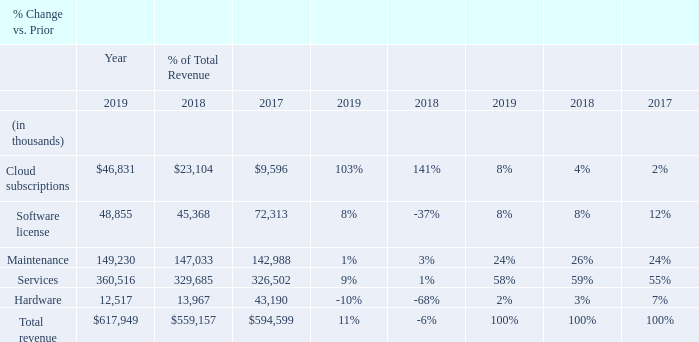Revenue
Our revenue consists of fees generated from cloud subscriptions, software licensing, maintenance, professional services, and hardware sales.
Cloud Subscriptions Revenue Year 2019 compared with year 2018 In 2017, we released Manhattan Active™ Solutions accelerating our business transition to cloud subscriptions. As a result, cloud subscriptions revenue increased $23.7 million, or 103%, to $46.8 million in 2019 compared to 2018 as customers began to purchase. our SaaS offerings rather than a traditional perpetual license. Our customers increasingly prefer cloud-based solutions, including existing customers that are migrating from on-premise to cloud-based offerings. Cloud subscriptions revenue for the Americas, EMEA and APAC segments increased $20.3 million, $2.7 million and $0.7 million, respectively.
Year 2018 compared with year 2017
Cloud subscriptions revenue increased $13.5 million to $23.1 million in 2018 compared to 2017 as customers began to purchase our SaaS offerings rather than a traditional perpetual license. Cloud subscriptions revenue for the Americas, EMEA and APAC segments increased $11.3 million, $1.8 million and $0.4 million, respectively. The EMEA segment began recognizing cloud subscription revenue for the first time in 2017 while the APAC segment began in 2018.
Software License Revenue Year 2019 compared with year 2018 Software license revenue increased $3.5 million to $48.9 million in 2019 compared to 2018. License revenue for the Americas and EMEA segments increased $6.1 million and $0.1 million, respectively, and license revenue for the APAC segment decreased $2.7 million, in 2019 over 2018. The perpetual license sales percentage mix across our product suite in 2019 was approximately 80% warehouse management solutions.
Year 2018 compared with year 2017 Software license revenue decreased $26.9 million to $45.4 million in 2018 compared to 2017. The decrease was influenced by (1) extended sales cycles and evaluations for some of our contracts, and (2) the business transition to cloud subscriptions, which resulted in traditional perpetual license deals closing as cloud deals based on customer demand. License revenue for the Americas and EMEA segments decreased $15.7 million and $11.5 million, respectively, in 2018 over 2017, while license revenue for the APAC segment increased $0.3 million. The perpetual license sales percentage mix across our product suite in 2018 was approximately 80% warehouse management solutions.
Software license revenue decreased $26.9 million to $45.4 million in 2018 compared to 2017. The decrease was influenced by (1)
extended sales cycles and evaluations for some of our contracts, and (2) the business transition to cloud subscriptions, which resulted
in traditional perpetual license deals closing as cloud deals based on customer demand. License revenue for the Americas and EMEA segments decreased $15.7 million and $11.5 million, respectively, in 2018 over 2017, while license revenue for the APAC segment increased $0.3 million. The perpetual license sales percentage mix across our product suite in 2018 was approximately 80% warehouse management solutions.
Maintenance Revenue
Year 2019 compared with year 2018
Maintenance revenue increased $2.2 million in 2019 compared to 2018 primarily due to (1) an increase in the first-year maintenance revenue; (2) our annual renewal rate of customers subscribing to maintenance, which was greater than 90%; and (3) increases in the maintenance renewal prices. Maintenance revenue for the Americas, EMEA and APAC segments increased $1.4 million, $0.4 million and $0.4 million, respectively, compared to 2018.
Year 2018 compared with year 2017
Maintenance revenue increased $4.0 million in 2018 compared to 2017 primarily due to (1) an increase in the first-year maintenance revenue; (2) our annual renewal rate of customers subscribing to maintenance, which was greater than 90%; and (3) increases in the maintenance renewal prices. Maintenance revenue for the Americas, EMEA and APAC segments increased $1.1 million, $2.2 million and $0.7 million, respectively, compared to 2017.
Services Revenue Year 2019 compared with year 2018 Services revenue increased $30.8 million, or 9%, in 2019 compared to 2018. The Americas, EMEA and APAC segments increased $17.8 million, $10.3 million and $2.7 million, respectively, compared to 2018.
Year 2019 compared with year 2018
Services revenue increased $30.8 million, or 9%, in 2019 compared to 2018. The Americas, EMEA and APAC segments increased $17.8 million, $10.3 million and $2.7 million, respectively, compared to 2018.
Year 2018 compared with year 2017 Services revenue increased $3.2 million in 2018 compared to 2017 primarily due to improving demand in the Americas and solid growth in EMEA. Services revenue for the Americas and EMEA segment increased $1.0 million and $6.9 million, respectively, and services revenue for the APAC segment decreased $4.7 million, compared to 2017.
Services revenue increased $3.2 million in 2018 compared to 2017 primarily due to improving demand in the Americas and solid growth in EMEA. Services revenue for the Americas and EMEA segment increased $1.0 million and $6.9 million, respectively, and services revenue for the APAC segment decreased $4.7 million, compared to 2017.
Hardware
Hardware sales, net decreased $1.5 million, or -10% in 2019 compared to 2018. We adopted the new ASC 606 standard as of
January 1, 2018 and elected to use the modified retrospective method. Historical hardware sales prior to the adoption of ASC 606
were recorded on a gross basis, as we were the principal in the transaction in accordance with the previous standard, ASC 605-45.
Under the new standard, we are an agent in the transaction as we do not physically control the hardware which we sell. Accordingly, starting January 1, 2018, we recognize our hardware revenue net of related cost which reduces both hardware revenue and cost of sales as compared to our accounting prior to 2018. For comparison purposes only, had we implemented ASC 606 using the full
retrospective method, we would have also presented hardware revenue net of cost for prior periods as shown below.
What is the difference in services revenue from 2018 to 2019? $30.8 million. What is the increase in cloud subscription revenue in America in 2019? $20.3 million. What is the perpetual license sales percentages mix across product suite in 2019? Approximately 80% warehouse management solutions. What is the change in percentage of total revenue for cloud subscriptions in 2019 and 2018?
Answer scale should be: percent. 8%-4%
Answer: 4. What is the difference in increase in software license revenue between America and EMEA in 2019?
Answer scale should be: million. $6.1-0.1
Answer: 6. What is the difference in increase in services revenue between America and APAC in 2019?
Answer scale should be: million. $17.8-2.7
Answer: 15.1. 